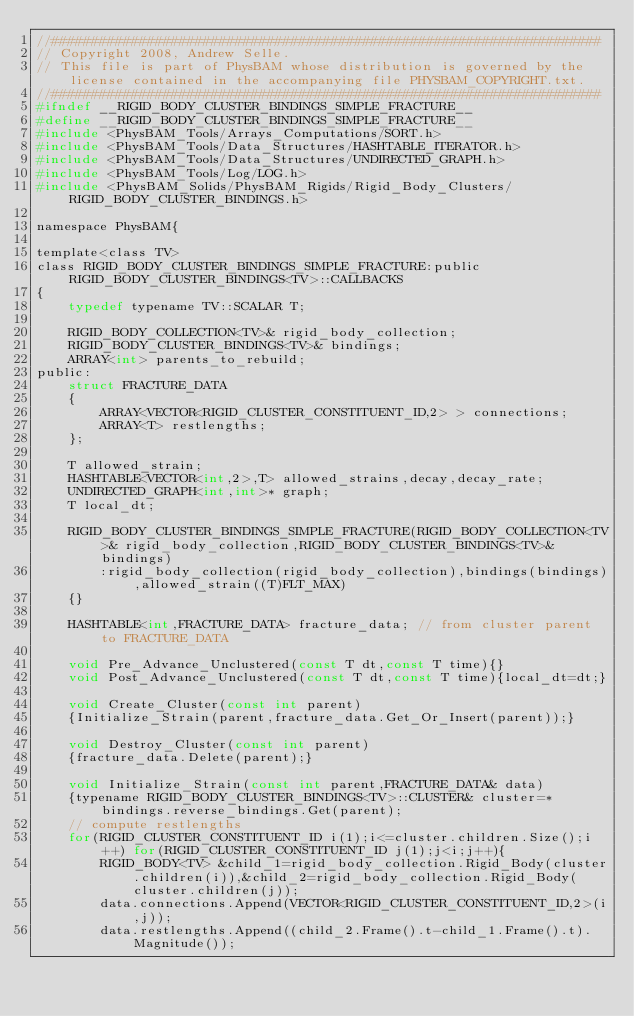Convert code to text. <code><loc_0><loc_0><loc_500><loc_500><_C_>//#####################################################################
// Copyright 2008, Andrew Selle.
// This file is part of PhysBAM whose distribution is governed by the license contained in the accompanying file PHYSBAM_COPYRIGHT.txt.
//#####################################################################
#ifndef __RIGID_BODY_CLUSTER_BINDINGS_SIMPLE_FRACTURE__
#define __RIGID_BODY_CLUSTER_BINDINGS_SIMPLE_FRACTURE__
#include <PhysBAM_Tools/Arrays_Computations/SORT.h>
#include <PhysBAM_Tools/Data_Structures/HASHTABLE_ITERATOR.h>
#include <PhysBAM_Tools/Data_Structures/UNDIRECTED_GRAPH.h>
#include <PhysBAM_Tools/Log/LOG.h>
#include <PhysBAM_Solids/PhysBAM_Rigids/Rigid_Body_Clusters/RIGID_BODY_CLUSTER_BINDINGS.h>

namespace PhysBAM{

template<class TV>
class RIGID_BODY_CLUSTER_BINDINGS_SIMPLE_FRACTURE:public RIGID_BODY_CLUSTER_BINDINGS<TV>::CALLBACKS
{
    typedef typename TV::SCALAR T;

    RIGID_BODY_COLLECTION<TV>& rigid_body_collection;
    RIGID_BODY_CLUSTER_BINDINGS<TV>& bindings;
    ARRAY<int> parents_to_rebuild;
public:
    struct FRACTURE_DATA
    {
        ARRAY<VECTOR<RIGID_CLUSTER_CONSTITUENT_ID,2> > connections;
        ARRAY<T> restlengths;
    };

    T allowed_strain;
    HASHTABLE<VECTOR<int,2>,T> allowed_strains,decay,decay_rate;
    UNDIRECTED_GRAPH<int,int>* graph;
    T local_dt;

    RIGID_BODY_CLUSTER_BINDINGS_SIMPLE_FRACTURE(RIGID_BODY_COLLECTION<TV>& rigid_body_collection,RIGID_BODY_CLUSTER_BINDINGS<TV>& bindings)
        :rigid_body_collection(rigid_body_collection),bindings(bindings),allowed_strain((T)FLT_MAX)
    {}

    HASHTABLE<int,FRACTURE_DATA> fracture_data; // from cluster parent to FRACTURE_DATA

    void Pre_Advance_Unclustered(const T dt,const T time){}
    void Post_Advance_Unclustered(const T dt,const T time){local_dt=dt;}

    void Create_Cluster(const int parent)
    {Initialize_Strain(parent,fracture_data.Get_Or_Insert(parent));}

    void Destroy_Cluster(const int parent)
    {fracture_data.Delete(parent);}

    void Initialize_Strain(const int parent,FRACTURE_DATA& data)
    {typename RIGID_BODY_CLUSTER_BINDINGS<TV>::CLUSTER& cluster=*bindings.reverse_bindings.Get(parent);
    // compute restlengths  
    for(RIGID_CLUSTER_CONSTITUENT_ID i(1);i<=cluster.children.Size();i++) for(RIGID_CLUSTER_CONSTITUENT_ID j(1);j<i;j++){
        RIGID_BODY<TV> &child_1=rigid_body_collection.Rigid_Body(cluster.children(i)),&child_2=rigid_body_collection.Rigid_Body(cluster.children(j));
        data.connections.Append(VECTOR<RIGID_CLUSTER_CONSTITUENT_ID,2>(i,j));
        data.restlengths.Append((child_2.Frame().t-child_1.Frame().t).Magnitude());</code> 